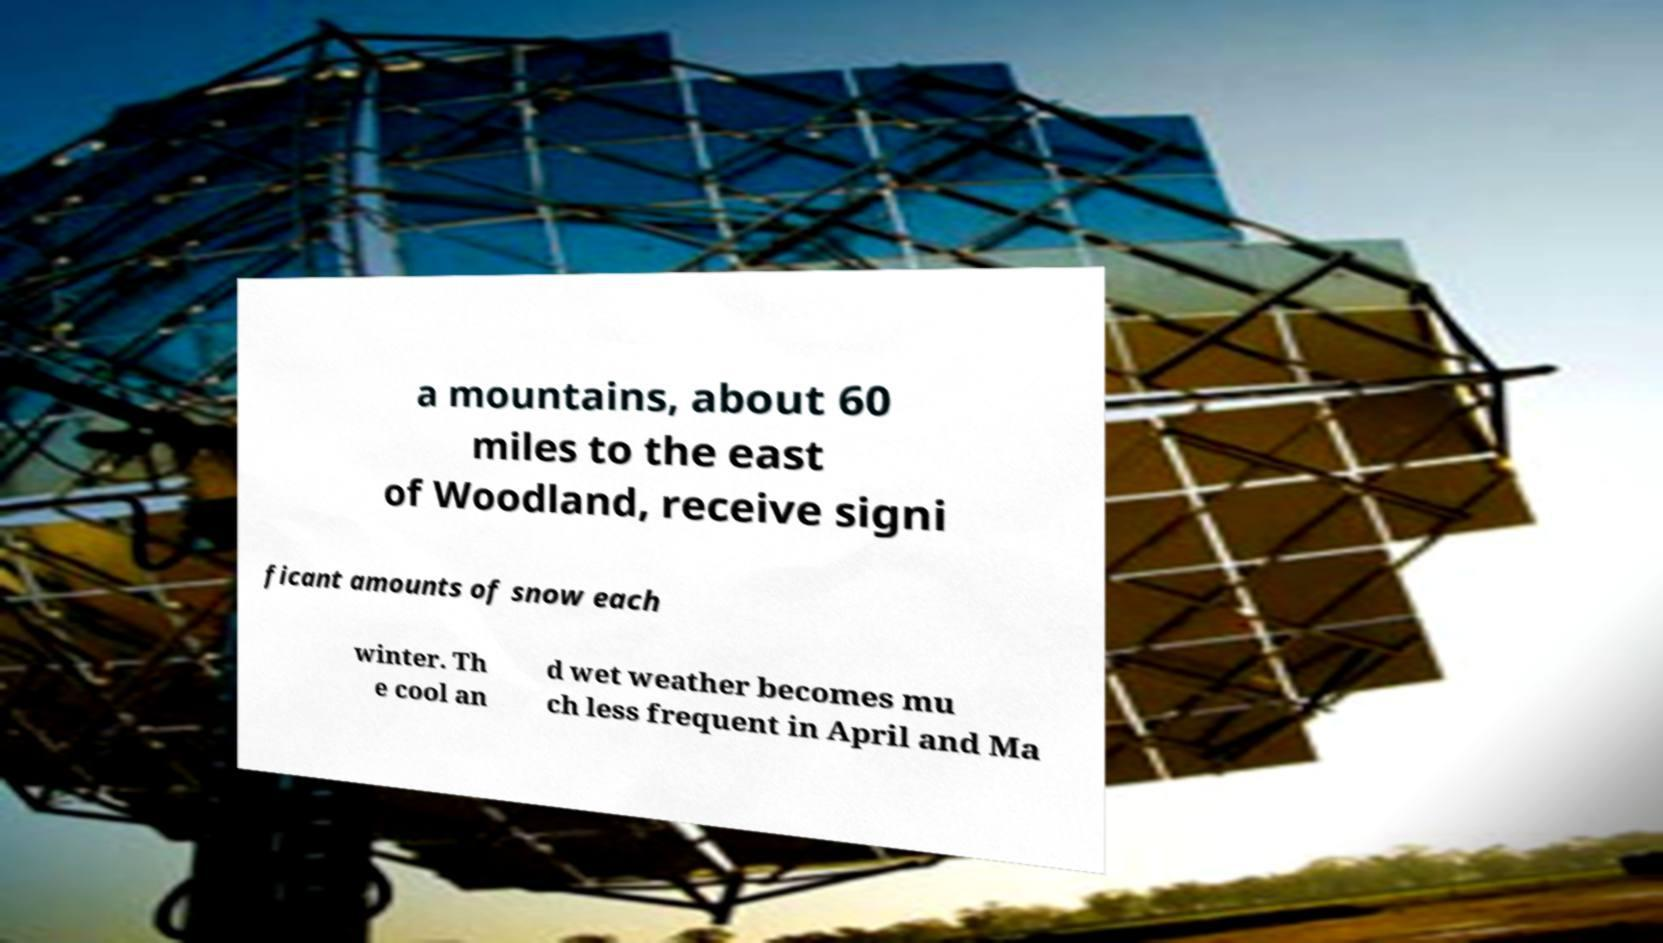What messages or text are displayed in this image? I need them in a readable, typed format. a mountains, about 60 miles to the east of Woodland, receive signi ficant amounts of snow each winter. Th e cool an d wet weather becomes mu ch less frequent in April and Ma 